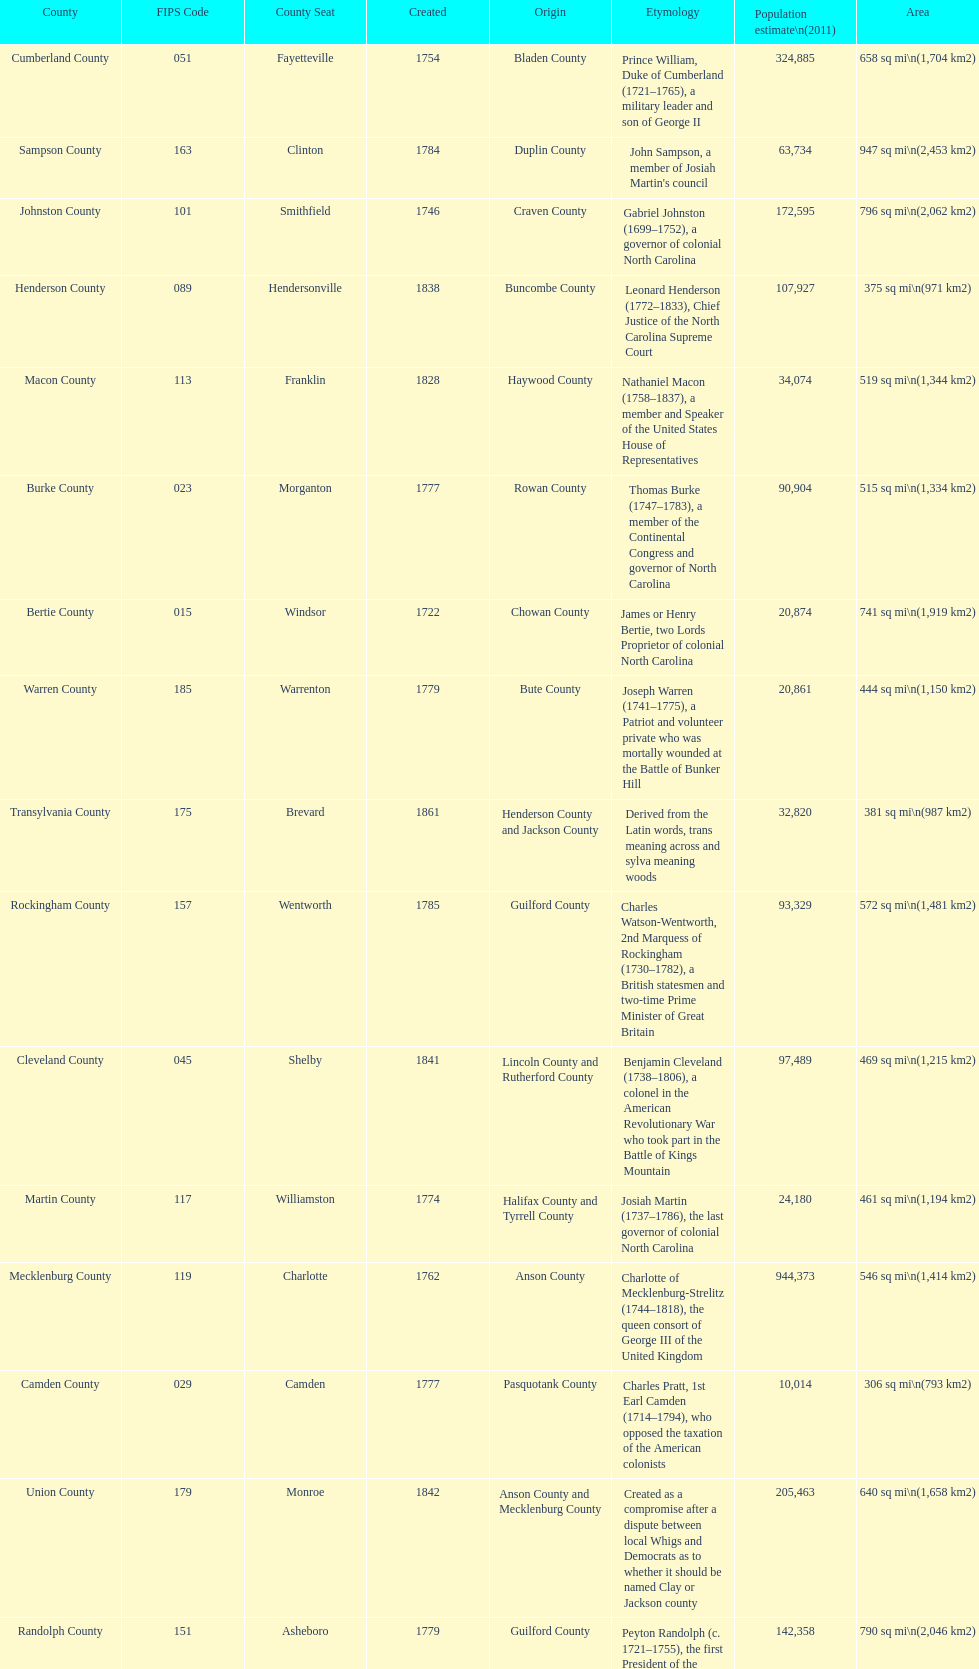Which county covers the most area? Dare County. 